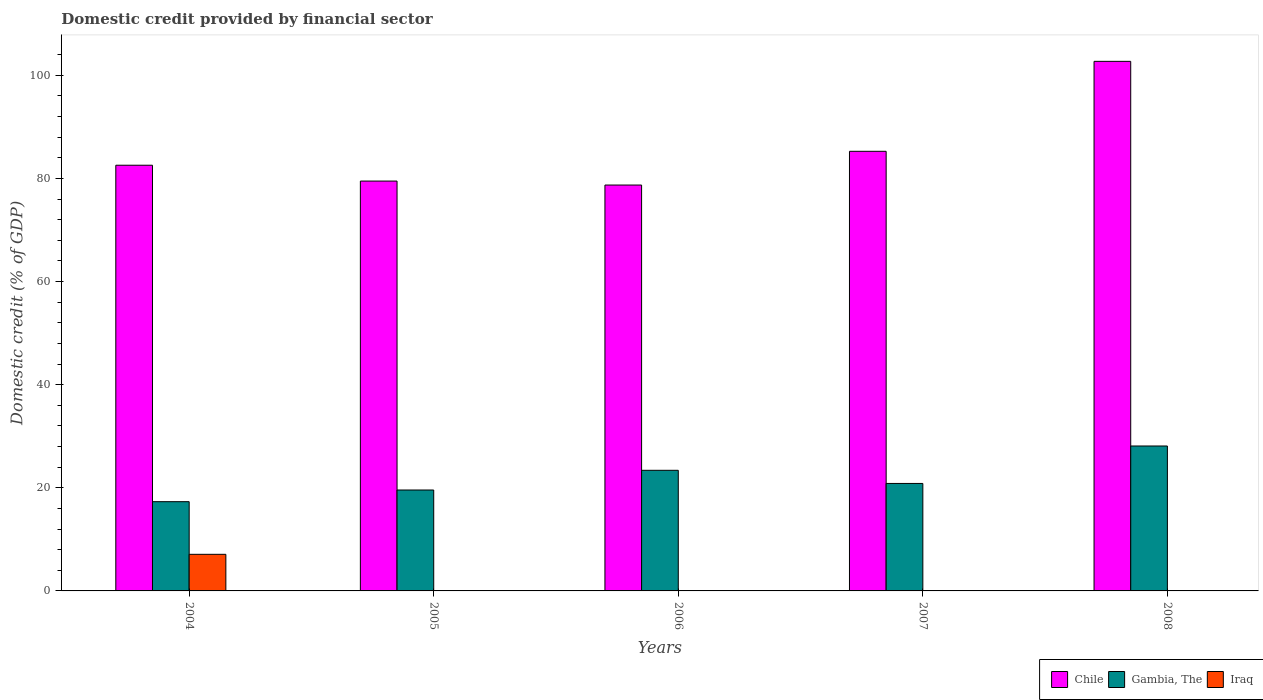How many groups of bars are there?
Give a very brief answer. 5. Are the number of bars on each tick of the X-axis equal?
Your answer should be very brief. No. What is the label of the 2nd group of bars from the left?
Ensure brevity in your answer.  2005. Across all years, what is the maximum domestic credit in Gambia, The?
Ensure brevity in your answer.  28.11. Across all years, what is the minimum domestic credit in Iraq?
Your answer should be very brief. 0. What is the total domestic credit in Iraq in the graph?
Keep it short and to the point. 7.1. What is the difference between the domestic credit in Gambia, The in 2004 and that in 2007?
Your answer should be compact. -3.54. What is the difference between the domestic credit in Iraq in 2008 and the domestic credit in Gambia, The in 2006?
Make the answer very short. -23.39. What is the average domestic credit in Chile per year?
Keep it short and to the point. 85.75. In the year 2008, what is the difference between the domestic credit in Gambia, The and domestic credit in Chile?
Offer a terse response. -74.6. In how many years, is the domestic credit in Iraq greater than 88 %?
Provide a short and direct response. 0. What is the ratio of the domestic credit in Chile in 2004 to that in 2006?
Offer a terse response. 1.05. What is the difference between the highest and the second highest domestic credit in Chile?
Offer a terse response. 17.45. What is the difference between the highest and the lowest domestic credit in Gambia, The?
Provide a short and direct response. 10.8. In how many years, is the domestic credit in Gambia, The greater than the average domestic credit in Gambia, The taken over all years?
Offer a very short reply. 2. Is the sum of the domestic credit in Gambia, The in 2005 and 2007 greater than the maximum domestic credit in Chile across all years?
Give a very brief answer. No. Are all the bars in the graph horizontal?
Ensure brevity in your answer.  No. How many legend labels are there?
Your answer should be compact. 3. How are the legend labels stacked?
Offer a very short reply. Horizontal. What is the title of the graph?
Provide a short and direct response. Domestic credit provided by financial sector. Does "Djibouti" appear as one of the legend labels in the graph?
Keep it short and to the point. No. What is the label or title of the X-axis?
Provide a succinct answer. Years. What is the label or title of the Y-axis?
Ensure brevity in your answer.  Domestic credit (% of GDP). What is the Domestic credit (% of GDP) in Chile in 2004?
Ensure brevity in your answer.  82.56. What is the Domestic credit (% of GDP) of Gambia, The in 2004?
Your response must be concise. 17.31. What is the Domestic credit (% of GDP) of Iraq in 2004?
Keep it short and to the point. 7.1. What is the Domestic credit (% of GDP) in Chile in 2005?
Make the answer very short. 79.49. What is the Domestic credit (% of GDP) of Gambia, The in 2005?
Your answer should be compact. 19.57. What is the Domestic credit (% of GDP) in Chile in 2006?
Offer a very short reply. 78.72. What is the Domestic credit (% of GDP) in Gambia, The in 2006?
Provide a succinct answer. 23.39. What is the Domestic credit (% of GDP) of Iraq in 2006?
Your response must be concise. 0. What is the Domestic credit (% of GDP) in Chile in 2007?
Offer a terse response. 85.26. What is the Domestic credit (% of GDP) of Gambia, The in 2007?
Provide a succinct answer. 20.85. What is the Domestic credit (% of GDP) of Iraq in 2007?
Offer a very short reply. 0. What is the Domestic credit (% of GDP) of Chile in 2008?
Your answer should be very brief. 102.71. What is the Domestic credit (% of GDP) in Gambia, The in 2008?
Make the answer very short. 28.11. What is the Domestic credit (% of GDP) of Iraq in 2008?
Offer a terse response. 0. Across all years, what is the maximum Domestic credit (% of GDP) of Chile?
Keep it short and to the point. 102.71. Across all years, what is the maximum Domestic credit (% of GDP) in Gambia, The?
Offer a terse response. 28.11. Across all years, what is the maximum Domestic credit (% of GDP) in Iraq?
Keep it short and to the point. 7.1. Across all years, what is the minimum Domestic credit (% of GDP) of Chile?
Ensure brevity in your answer.  78.72. Across all years, what is the minimum Domestic credit (% of GDP) in Gambia, The?
Make the answer very short. 17.31. Across all years, what is the minimum Domestic credit (% of GDP) of Iraq?
Provide a short and direct response. 0. What is the total Domestic credit (% of GDP) of Chile in the graph?
Ensure brevity in your answer.  428.75. What is the total Domestic credit (% of GDP) of Gambia, The in the graph?
Keep it short and to the point. 109.23. What is the total Domestic credit (% of GDP) of Iraq in the graph?
Offer a terse response. 7.1. What is the difference between the Domestic credit (% of GDP) in Chile in 2004 and that in 2005?
Your answer should be compact. 3.07. What is the difference between the Domestic credit (% of GDP) of Gambia, The in 2004 and that in 2005?
Your answer should be compact. -2.26. What is the difference between the Domestic credit (% of GDP) of Chile in 2004 and that in 2006?
Offer a terse response. 3.84. What is the difference between the Domestic credit (% of GDP) in Gambia, The in 2004 and that in 2006?
Provide a short and direct response. -6.08. What is the difference between the Domestic credit (% of GDP) in Chile in 2004 and that in 2007?
Provide a short and direct response. -2.7. What is the difference between the Domestic credit (% of GDP) of Gambia, The in 2004 and that in 2007?
Keep it short and to the point. -3.54. What is the difference between the Domestic credit (% of GDP) in Chile in 2004 and that in 2008?
Your answer should be compact. -20.15. What is the difference between the Domestic credit (% of GDP) in Gambia, The in 2004 and that in 2008?
Your response must be concise. -10.8. What is the difference between the Domestic credit (% of GDP) in Chile in 2005 and that in 2006?
Give a very brief answer. 0.77. What is the difference between the Domestic credit (% of GDP) of Gambia, The in 2005 and that in 2006?
Your answer should be compact. -3.82. What is the difference between the Domestic credit (% of GDP) in Chile in 2005 and that in 2007?
Give a very brief answer. -5.77. What is the difference between the Domestic credit (% of GDP) of Gambia, The in 2005 and that in 2007?
Offer a terse response. -1.27. What is the difference between the Domestic credit (% of GDP) in Chile in 2005 and that in 2008?
Keep it short and to the point. -23.22. What is the difference between the Domestic credit (% of GDP) of Gambia, The in 2005 and that in 2008?
Ensure brevity in your answer.  -8.54. What is the difference between the Domestic credit (% of GDP) in Chile in 2006 and that in 2007?
Ensure brevity in your answer.  -6.54. What is the difference between the Domestic credit (% of GDP) in Gambia, The in 2006 and that in 2007?
Give a very brief answer. 2.55. What is the difference between the Domestic credit (% of GDP) of Chile in 2006 and that in 2008?
Provide a succinct answer. -23.99. What is the difference between the Domestic credit (% of GDP) of Gambia, The in 2006 and that in 2008?
Your answer should be very brief. -4.72. What is the difference between the Domestic credit (% of GDP) of Chile in 2007 and that in 2008?
Offer a very short reply. -17.45. What is the difference between the Domestic credit (% of GDP) in Gambia, The in 2007 and that in 2008?
Offer a very short reply. -7.26. What is the difference between the Domestic credit (% of GDP) of Chile in 2004 and the Domestic credit (% of GDP) of Gambia, The in 2005?
Offer a very short reply. 62.99. What is the difference between the Domestic credit (% of GDP) of Chile in 2004 and the Domestic credit (% of GDP) of Gambia, The in 2006?
Ensure brevity in your answer.  59.17. What is the difference between the Domestic credit (% of GDP) in Chile in 2004 and the Domestic credit (% of GDP) in Gambia, The in 2007?
Your response must be concise. 61.72. What is the difference between the Domestic credit (% of GDP) in Chile in 2004 and the Domestic credit (% of GDP) in Gambia, The in 2008?
Make the answer very short. 54.45. What is the difference between the Domestic credit (% of GDP) in Chile in 2005 and the Domestic credit (% of GDP) in Gambia, The in 2006?
Ensure brevity in your answer.  56.1. What is the difference between the Domestic credit (% of GDP) of Chile in 2005 and the Domestic credit (% of GDP) of Gambia, The in 2007?
Your answer should be very brief. 58.65. What is the difference between the Domestic credit (% of GDP) of Chile in 2005 and the Domestic credit (% of GDP) of Gambia, The in 2008?
Your answer should be compact. 51.38. What is the difference between the Domestic credit (% of GDP) of Chile in 2006 and the Domestic credit (% of GDP) of Gambia, The in 2007?
Make the answer very short. 57.88. What is the difference between the Domestic credit (% of GDP) of Chile in 2006 and the Domestic credit (% of GDP) of Gambia, The in 2008?
Provide a succinct answer. 50.61. What is the difference between the Domestic credit (% of GDP) in Chile in 2007 and the Domestic credit (% of GDP) in Gambia, The in 2008?
Ensure brevity in your answer.  57.15. What is the average Domestic credit (% of GDP) of Chile per year?
Offer a very short reply. 85.75. What is the average Domestic credit (% of GDP) of Gambia, The per year?
Offer a very short reply. 21.85. What is the average Domestic credit (% of GDP) of Iraq per year?
Ensure brevity in your answer.  1.42. In the year 2004, what is the difference between the Domestic credit (% of GDP) of Chile and Domestic credit (% of GDP) of Gambia, The?
Keep it short and to the point. 65.25. In the year 2004, what is the difference between the Domestic credit (% of GDP) of Chile and Domestic credit (% of GDP) of Iraq?
Give a very brief answer. 75.47. In the year 2004, what is the difference between the Domestic credit (% of GDP) of Gambia, The and Domestic credit (% of GDP) of Iraq?
Provide a succinct answer. 10.21. In the year 2005, what is the difference between the Domestic credit (% of GDP) in Chile and Domestic credit (% of GDP) in Gambia, The?
Make the answer very short. 59.92. In the year 2006, what is the difference between the Domestic credit (% of GDP) of Chile and Domestic credit (% of GDP) of Gambia, The?
Offer a terse response. 55.33. In the year 2007, what is the difference between the Domestic credit (% of GDP) of Chile and Domestic credit (% of GDP) of Gambia, The?
Offer a terse response. 64.42. In the year 2008, what is the difference between the Domestic credit (% of GDP) in Chile and Domestic credit (% of GDP) in Gambia, The?
Provide a succinct answer. 74.6. What is the ratio of the Domestic credit (% of GDP) of Chile in 2004 to that in 2005?
Keep it short and to the point. 1.04. What is the ratio of the Domestic credit (% of GDP) of Gambia, The in 2004 to that in 2005?
Your answer should be compact. 0.88. What is the ratio of the Domestic credit (% of GDP) of Chile in 2004 to that in 2006?
Provide a succinct answer. 1.05. What is the ratio of the Domestic credit (% of GDP) of Gambia, The in 2004 to that in 2006?
Keep it short and to the point. 0.74. What is the ratio of the Domestic credit (% of GDP) of Chile in 2004 to that in 2007?
Make the answer very short. 0.97. What is the ratio of the Domestic credit (% of GDP) of Gambia, The in 2004 to that in 2007?
Provide a short and direct response. 0.83. What is the ratio of the Domestic credit (% of GDP) of Chile in 2004 to that in 2008?
Your answer should be very brief. 0.8. What is the ratio of the Domestic credit (% of GDP) in Gambia, The in 2004 to that in 2008?
Make the answer very short. 0.62. What is the ratio of the Domestic credit (% of GDP) of Chile in 2005 to that in 2006?
Give a very brief answer. 1.01. What is the ratio of the Domestic credit (% of GDP) in Gambia, The in 2005 to that in 2006?
Offer a very short reply. 0.84. What is the ratio of the Domestic credit (% of GDP) in Chile in 2005 to that in 2007?
Offer a terse response. 0.93. What is the ratio of the Domestic credit (% of GDP) of Gambia, The in 2005 to that in 2007?
Your answer should be very brief. 0.94. What is the ratio of the Domestic credit (% of GDP) in Chile in 2005 to that in 2008?
Ensure brevity in your answer.  0.77. What is the ratio of the Domestic credit (% of GDP) of Gambia, The in 2005 to that in 2008?
Offer a terse response. 0.7. What is the ratio of the Domestic credit (% of GDP) in Chile in 2006 to that in 2007?
Your response must be concise. 0.92. What is the ratio of the Domestic credit (% of GDP) in Gambia, The in 2006 to that in 2007?
Your response must be concise. 1.12. What is the ratio of the Domestic credit (% of GDP) in Chile in 2006 to that in 2008?
Provide a short and direct response. 0.77. What is the ratio of the Domestic credit (% of GDP) in Gambia, The in 2006 to that in 2008?
Offer a terse response. 0.83. What is the ratio of the Domestic credit (% of GDP) of Chile in 2007 to that in 2008?
Make the answer very short. 0.83. What is the ratio of the Domestic credit (% of GDP) in Gambia, The in 2007 to that in 2008?
Your answer should be very brief. 0.74. What is the difference between the highest and the second highest Domestic credit (% of GDP) of Chile?
Make the answer very short. 17.45. What is the difference between the highest and the second highest Domestic credit (% of GDP) in Gambia, The?
Offer a terse response. 4.72. What is the difference between the highest and the lowest Domestic credit (% of GDP) of Chile?
Offer a very short reply. 23.99. What is the difference between the highest and the lowest Domestic credit (% of GDP) of Gambia, The?
Keep it short and to the point. 10.8. What is the difference between the highest and the lowest Domestic credit (% of GDP) in Iraq?
Make the answer very short. 7.1. 